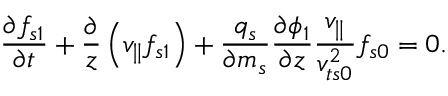Convert formula to latex. <formula><loc_0><loc_0><loc_500><loc_500>\frac { \partial f _ { s 1 } } { \partial t } + \frac { \partial } { z } \left ( v _ { \| } f _ { s 1 } \right ) + \frac { q _ { s } } { \partial m _ { s } } \frac { \partial \phi _ { 1 } } { \partial z } \frac { v _ { \| } } { v _ { t s 0 } ^ { 2 } } f _ { s 0 } = 0 .</formula> 